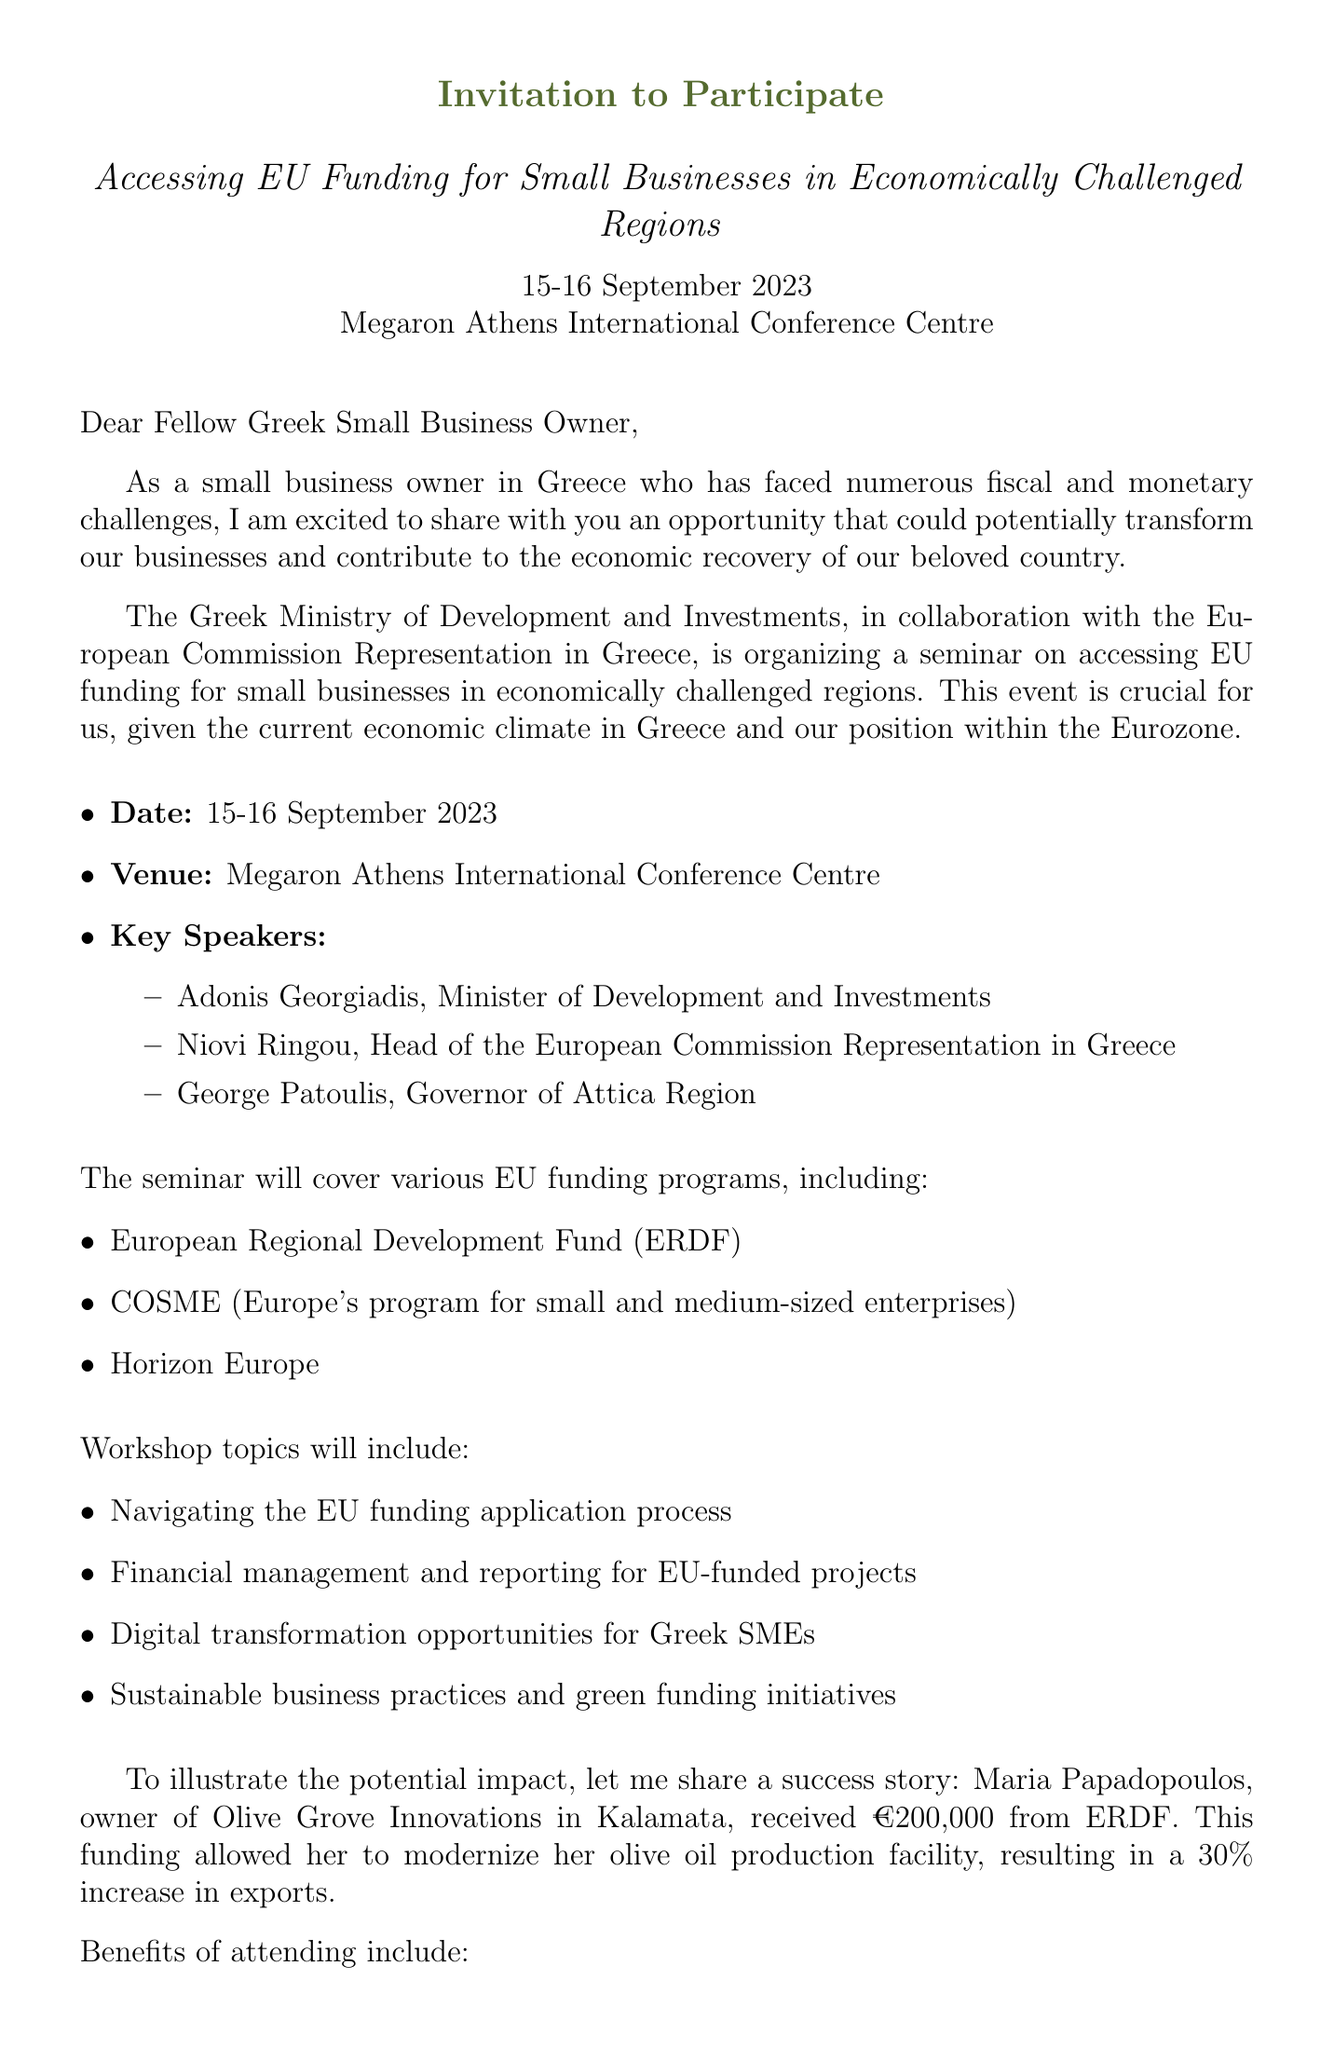What are the dates of the seminar? The seminar is scheduled for 15-16 September 2023, as stated in the document.
Answer: 15-16 September 2023 Who organizes the seminar? The Greek Ministry of Development and Investments is the organizer of the seminar.
Answer: Greek Ministry of Development and Investments What is the venue for the seminar? The seminar will take place at the Megaron Athens International Conference Centre, which is mentioned in the document.
Answer: Megaron Athens International Conference Centre Name one funding program mentioned in the document. The document lists multiple funding programs such as the European Regional Development Fund.
Answer: European Regional Development Fund What is one benefit of attending the seminar? One benefit stated in the document is the opportunity for one-on-one consultations with EU funding experts.
Answer: One-on-one consultations with EU funding experts What is required for business eligibility? The document outlines that being a registered small business in Greece is a key eligibility criterion.
Answer: Registered small business in Greece Who is one of the key speakers at the seminar? The document lists Adonis Georgiadis as one of the key speakers.
Answer: Adonis Georgiadis What is the registration deadline? The document specifies that the registration deadline is 31 August 2023.
Answer: 31 August 2023 What type of document is this? This document is an invitation letter, as indicated by the initial text and format.
Answer: Invitation letter 